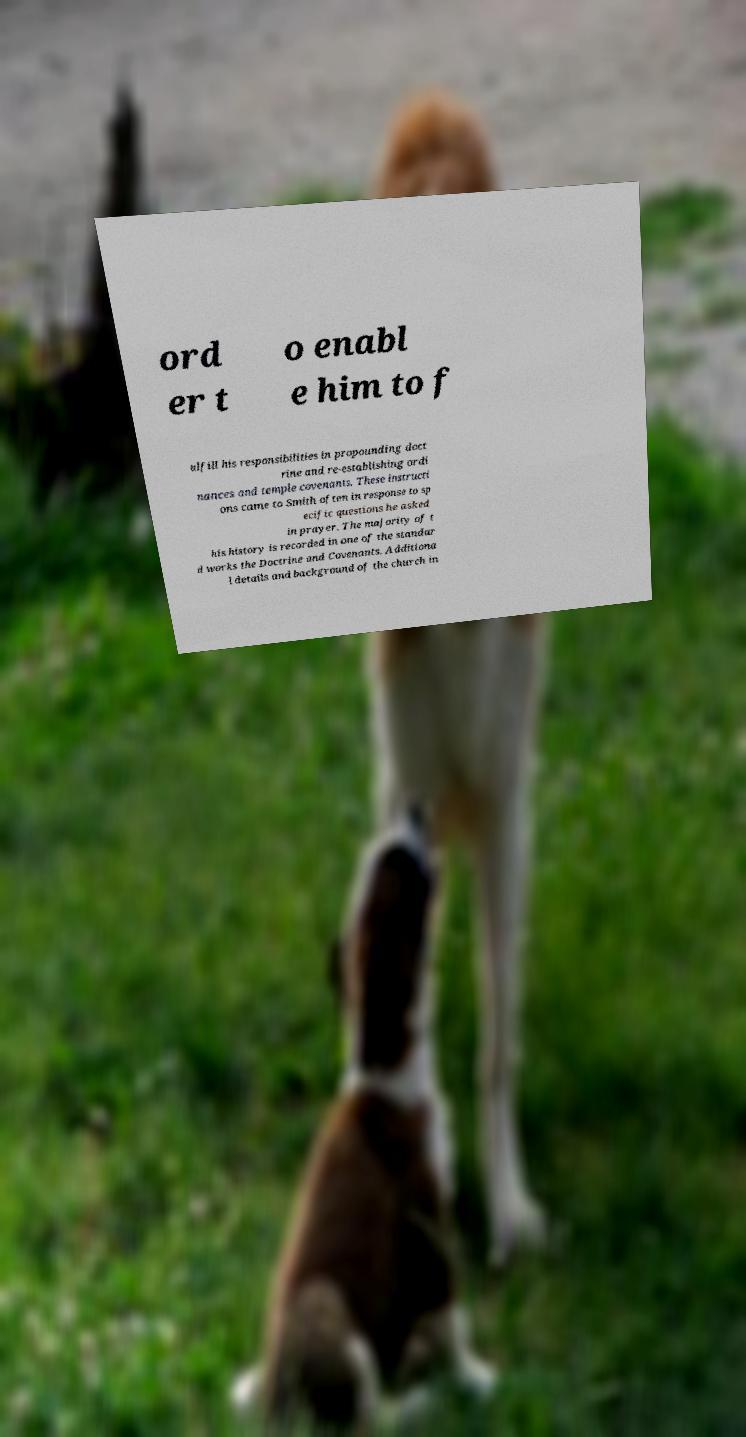Please read and relay the text visible in this image. What does it say? ord er t o enabl e him to f ulfill his responsibilities in propounding doct rine and re-establishing ordi nances and temple covenants. These instructi ons came to Smith often in response to sp ecific questions he asked in prayer. The majority of t his history is recorded in one of the standar d works the Doctrine and Covenants. Additiona l details and background of the church in 